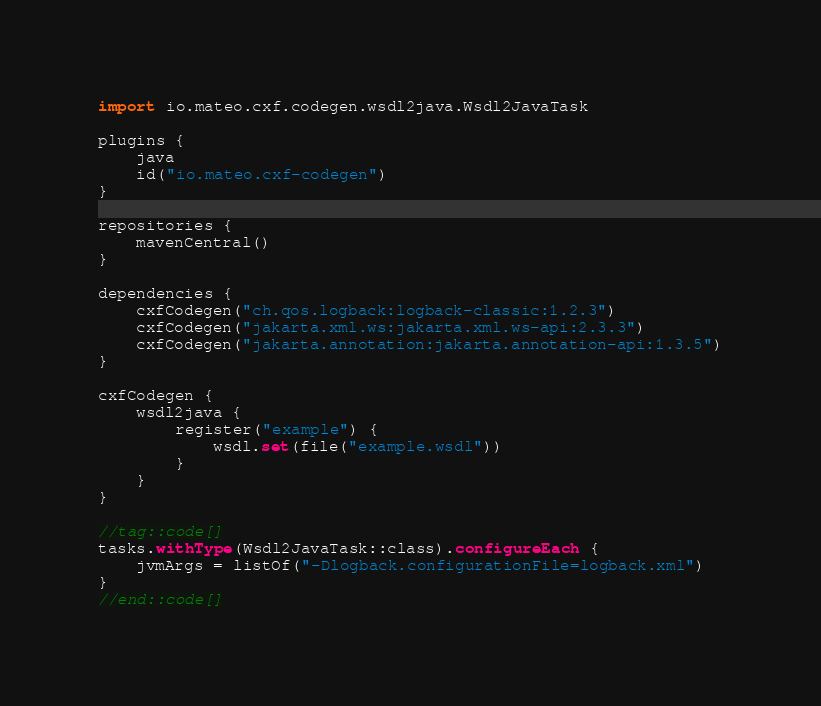<code> <loc_0><loc_0><loc_500><loc_500><_Kotlin_>import io.mateo.cxf.codegen.wsdl2java.Wsdl2JavaTask

plugins {
    java
    id("io.mateo.cxf-codegen")
}

repositories {
    mavenCentral()
}

dependencies {
    cxfCodegen("ch.qos.logback:logback-classic:1.2.3")
    cxfCodegen("jakarta.xml.ws:jakarta.xml.ws-api:2.3.3")
    cxfCodegen("jakarta.annotation:jakarta.annotation-api:1.3.5")
}

cxfCodegen {
    wsdl2java {
        register("example") {
            wsdl.set(file("example.wsdl"))
        }
    }
}

//tag::code[]
tasks.withType(Wsdl2JavaTask::class).configureEach {
    jvmArgs = listOf("-Dlogback.configurationFile=logback.xml")
}
//end::code[]
</code> 